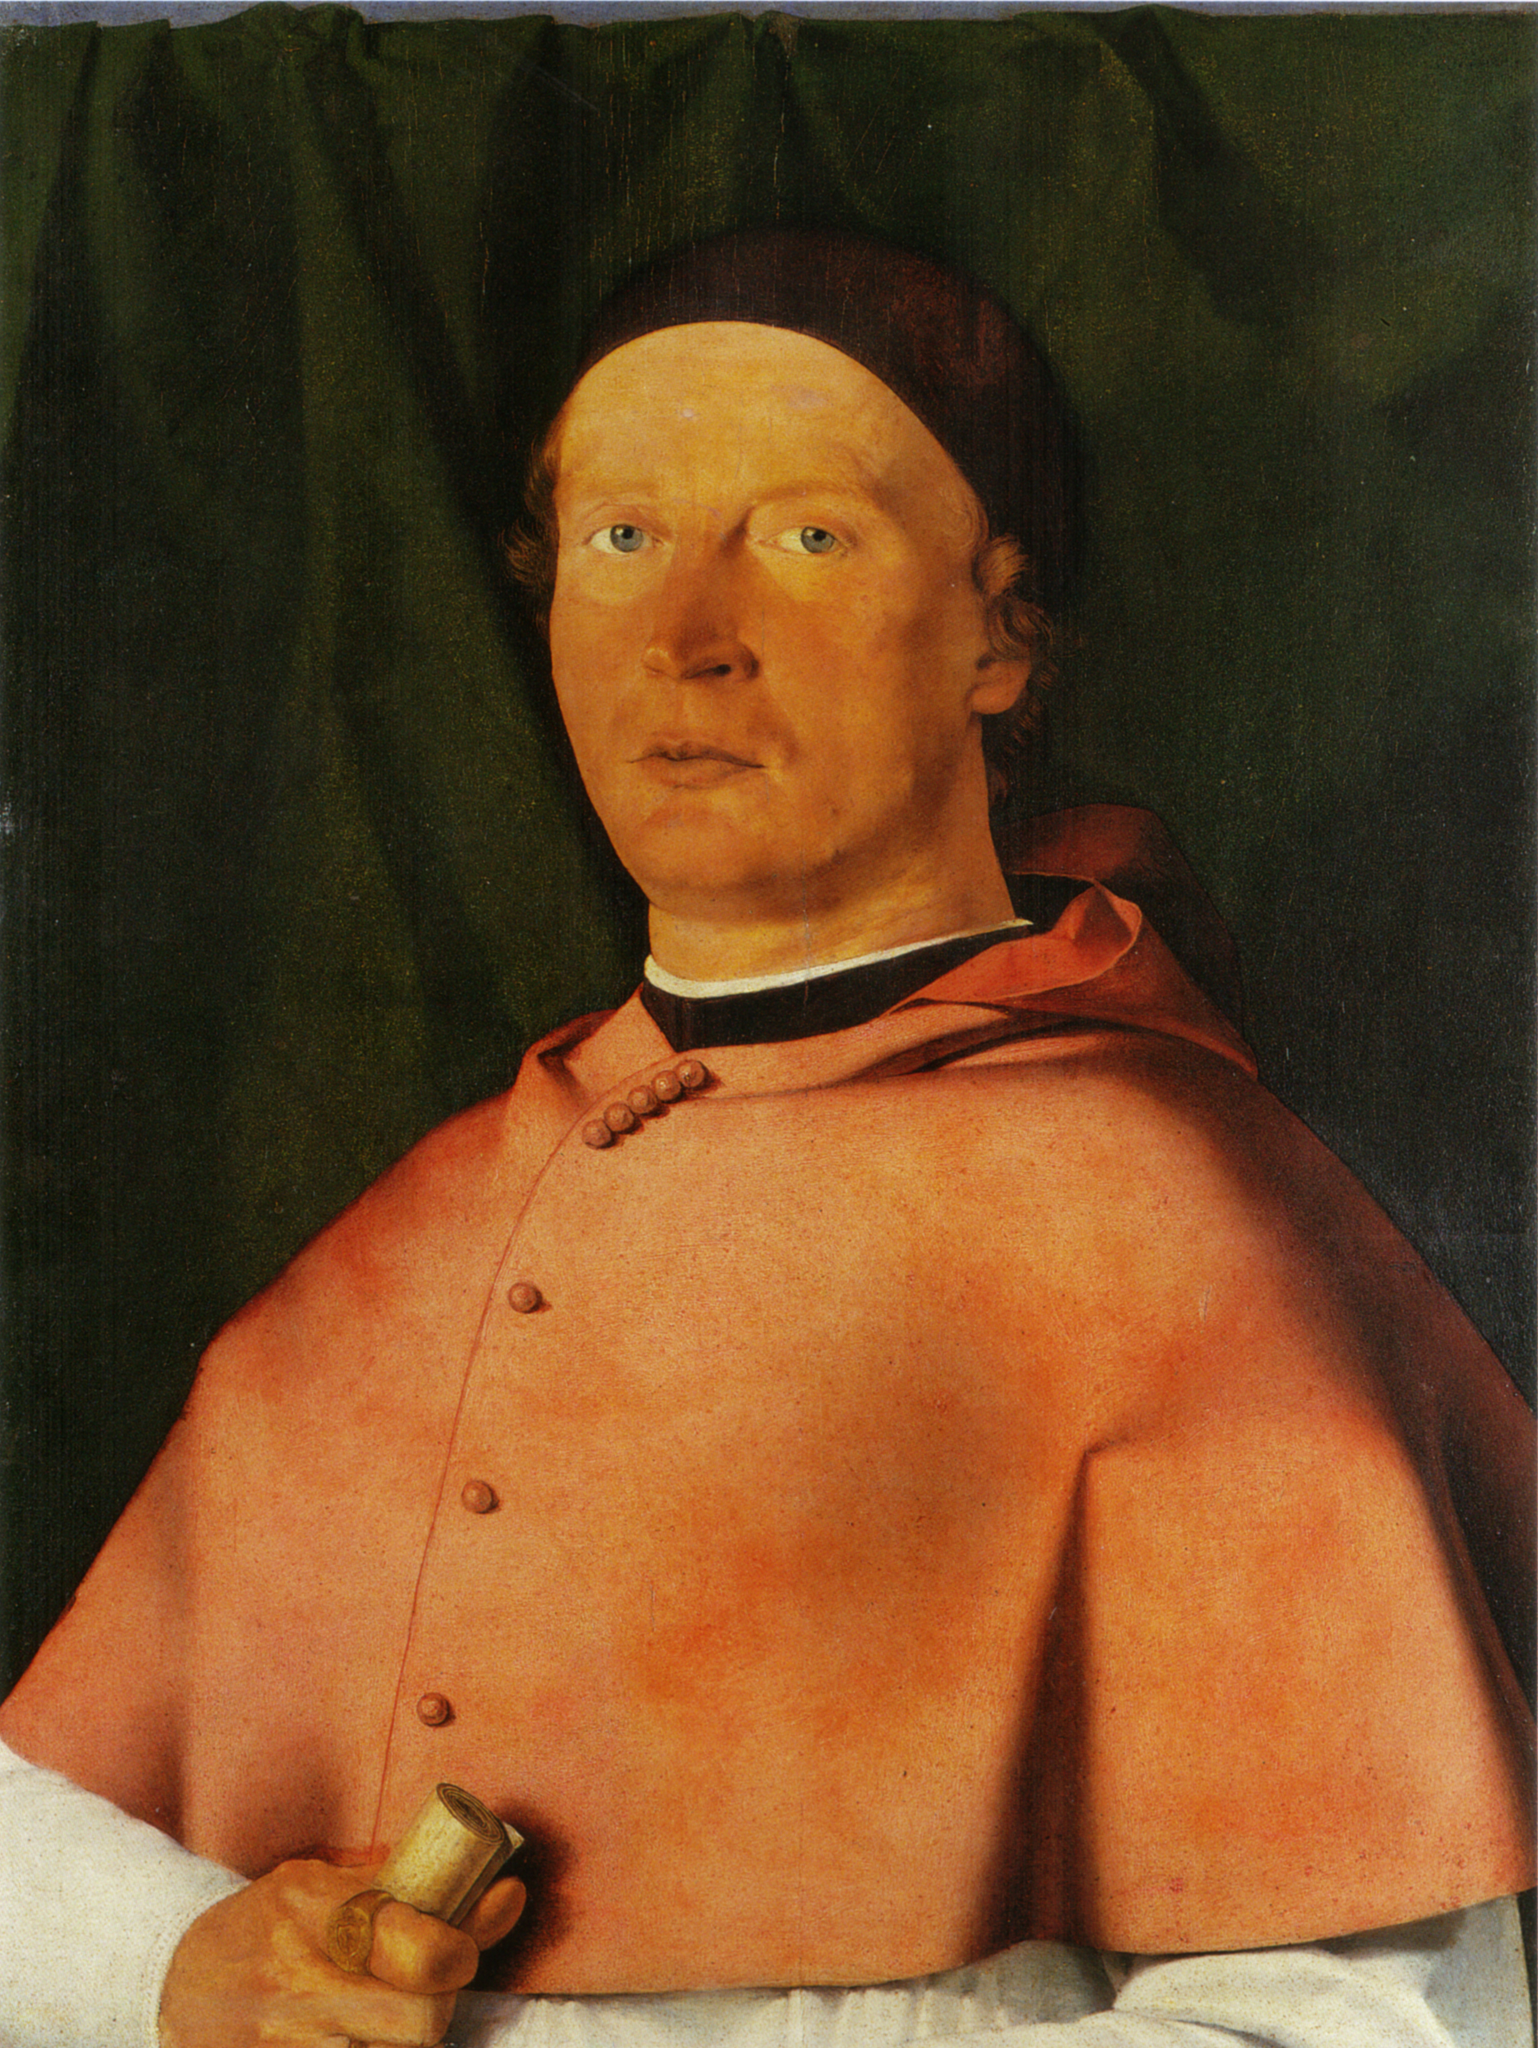What do you think is going on in this snapshot? The image depicts a man, portrayed in a realistic style characteristic of portraiture. He is dressed in a vibrant red robe and a black cap, holding a small gold object in his right hand. The background features a dark green curtain, providing a stark contrast to the man's attire. The painting medium appears to be oil on panel, further enhancing the richness of the colors used, mainly red, black, and green. The attention to detail and the use of light and shadow suggest a high level of skill and technique. The overall composition and the man's attire suggest a sense of importance and status. The small gold object he holds could possibly signify wealth or power. The realistic portrayal of the man and the objects around him, along with the use of a limited color palette, create a sense of depth and three-dimensionality in the painting. The artist has successfully captured not only the physical attributes of the man but also a glimpse into his character and status. 